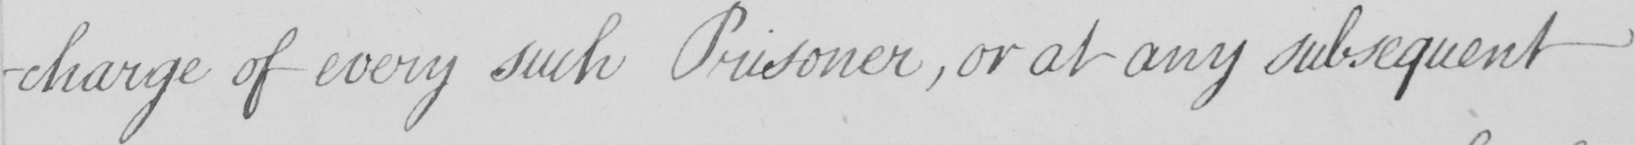Transcribe the text shown in this historical manuscript line. -charge of every such Prisoner  , or at any subsequent 